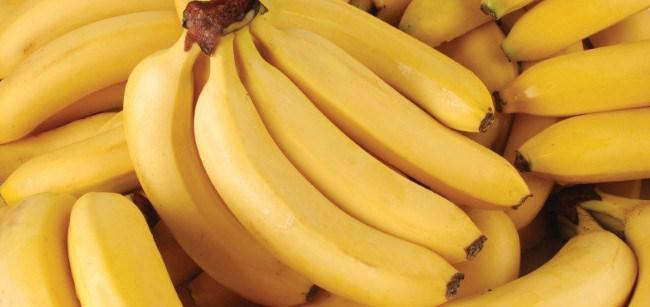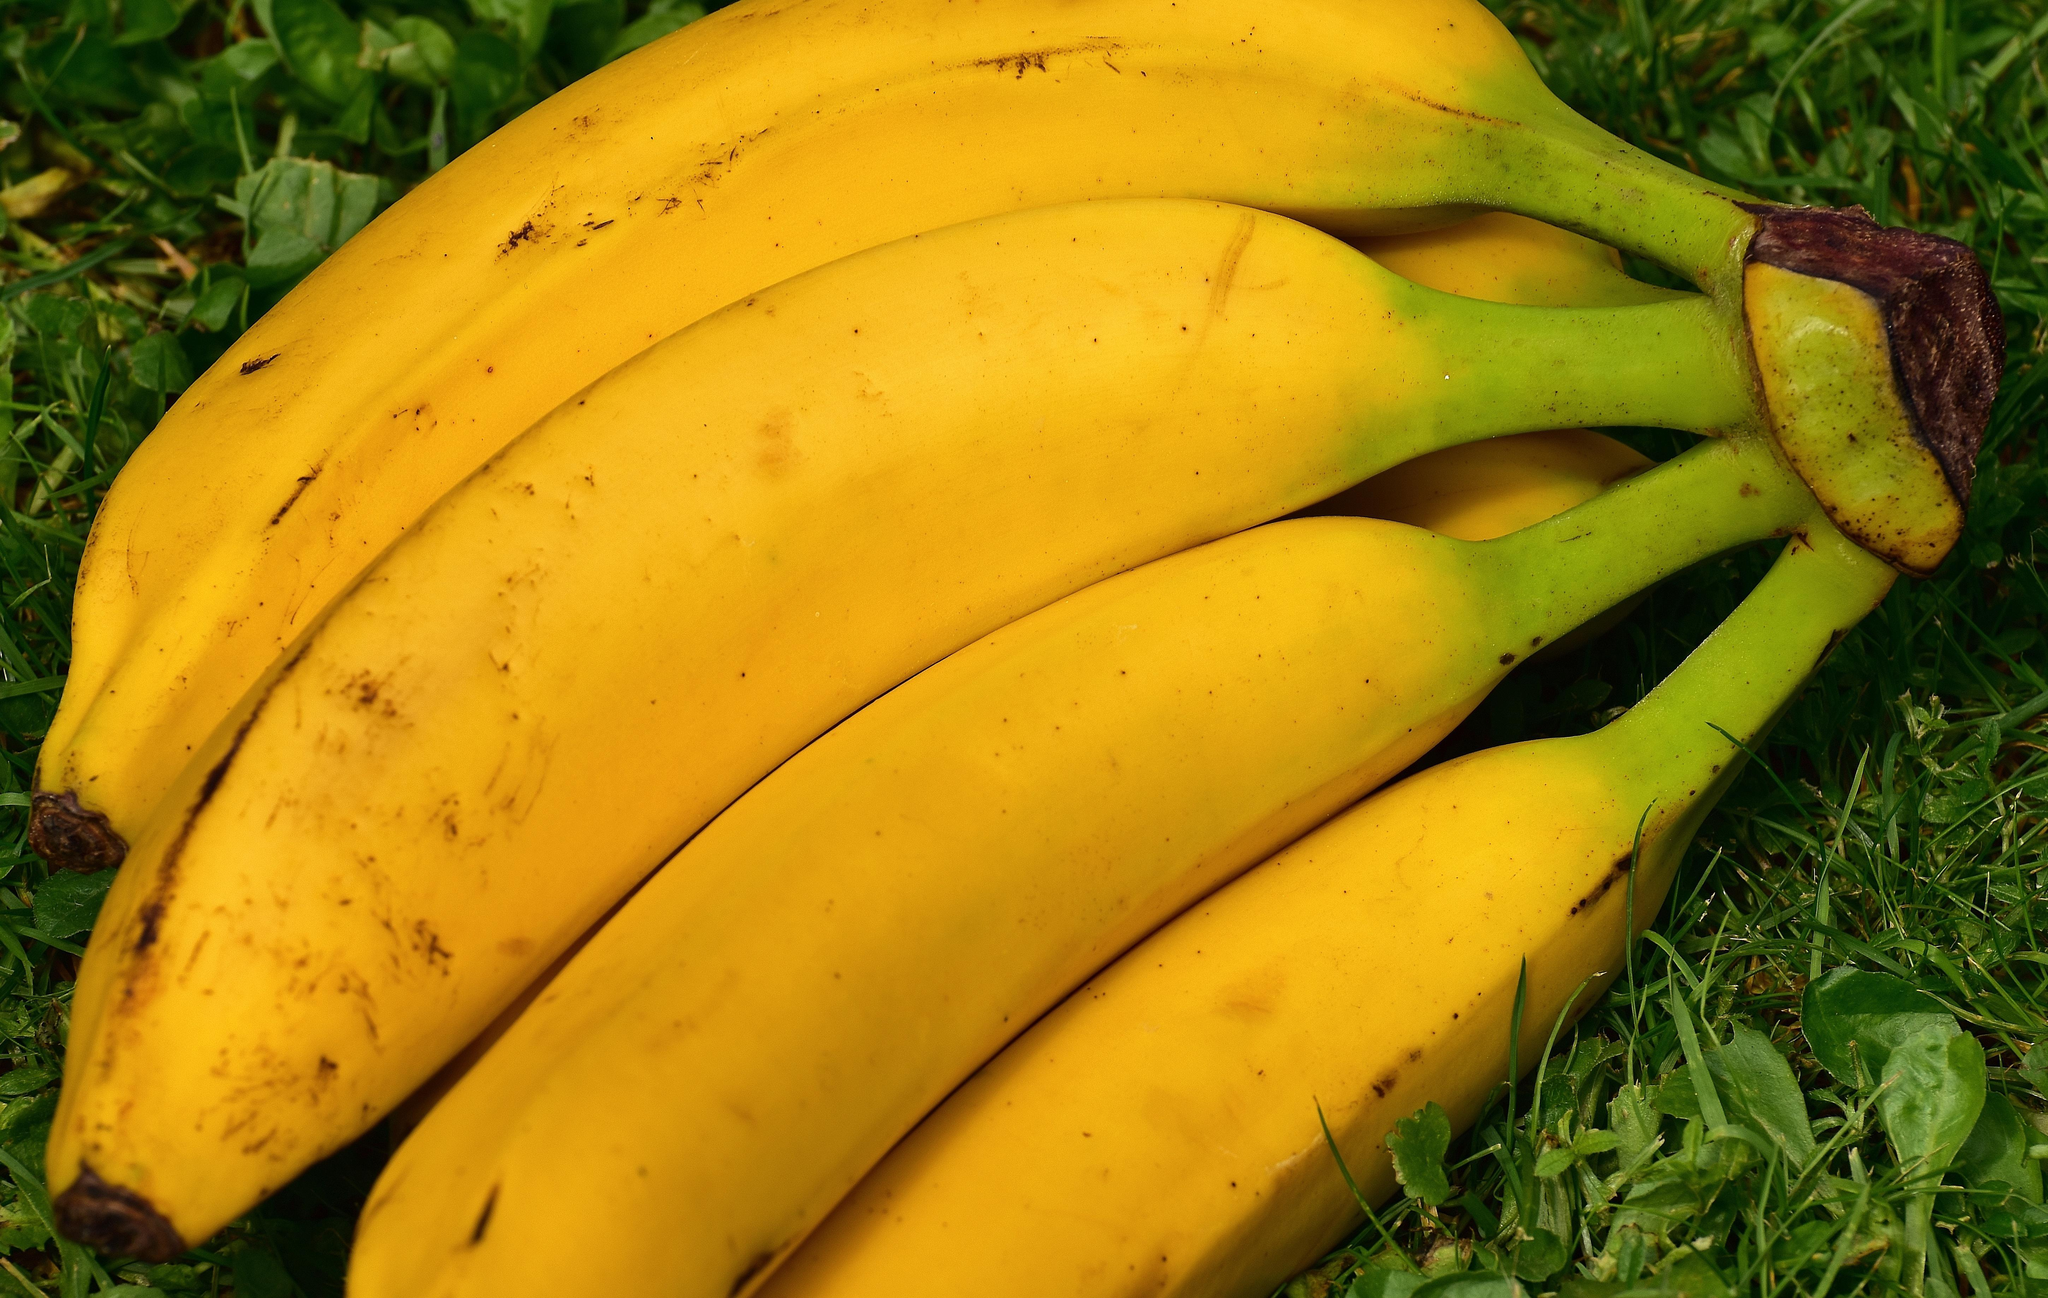The first image is the image on the left, the second image is the image on the right. Considering the images on both sides, is "All the bananas in the right image are in a bunch." valid? Answer yes or no. Yes. 